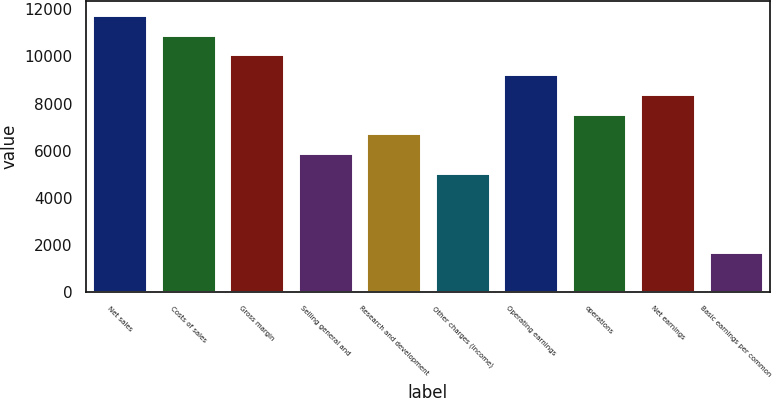Convert chart to OTSL. <chart><loc_0><loc_0><loc_500><loc_500><bar_chart><fcel>Net sales<fcel>Costs of sales<fcel>Gross margin<fcel>Selling general and<fcel>Research and development<fcel>Other charges (income)<fcel>Operating earnings<fcel>operations<fcel>Net earnings<fcel>Basic earnings per common<nl><fcel>11771.2<fcel>10930.4<fcel>10089.6<fcel>5885.64<fcel>6726.44<fcel>5044.84<fcel>9248.84<fcel>7567.24<fcel>8408.04<fcel>1681.64<nl></chart> 